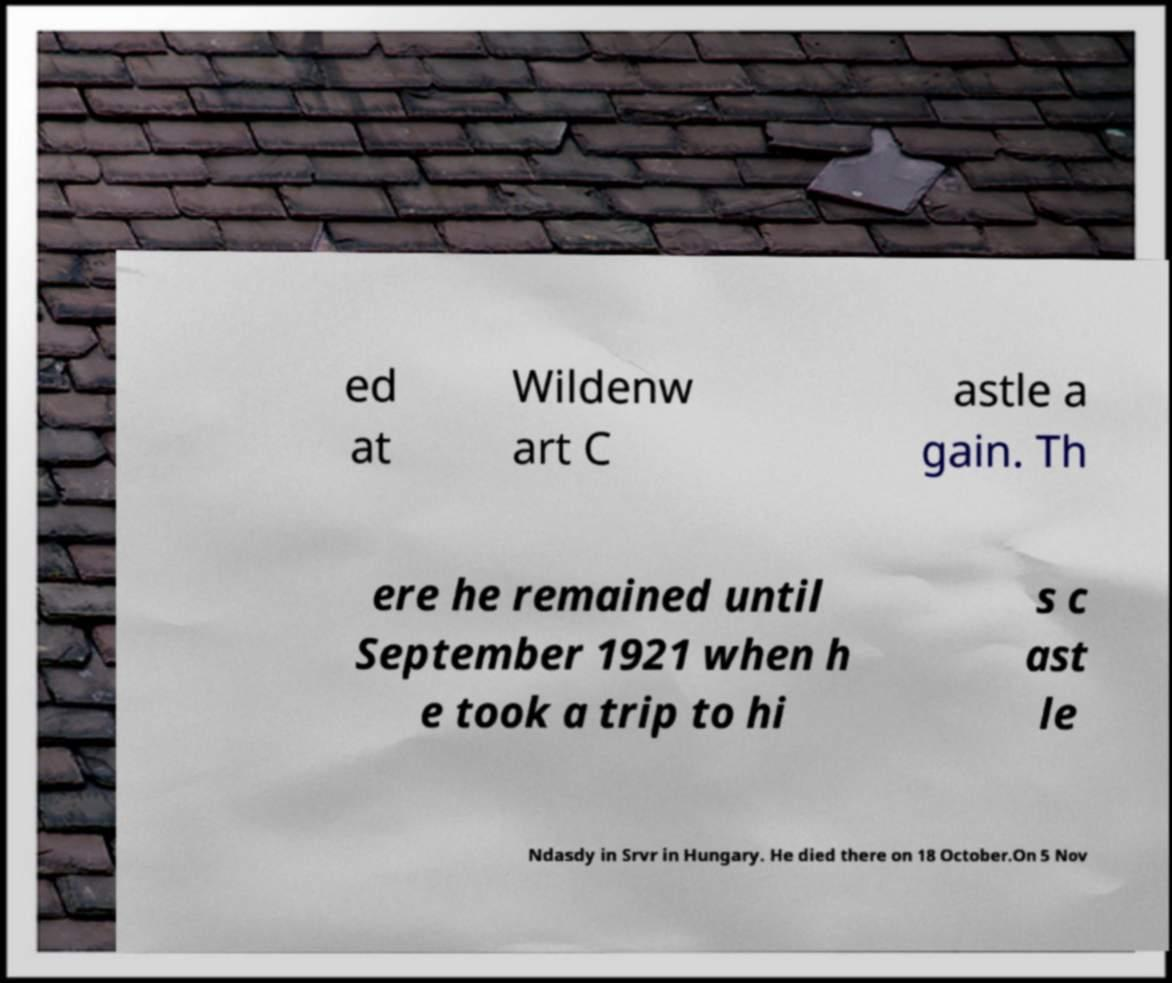I need the written content from this picture converted into text. Can you do that? ed at Wildenw art C astle a gain. Th ere he remained until September 1921 when h e took a trip to hi s c ast le Ndasdy in Srvr in Hungary. He died there on 18 October.On 5 Nov 